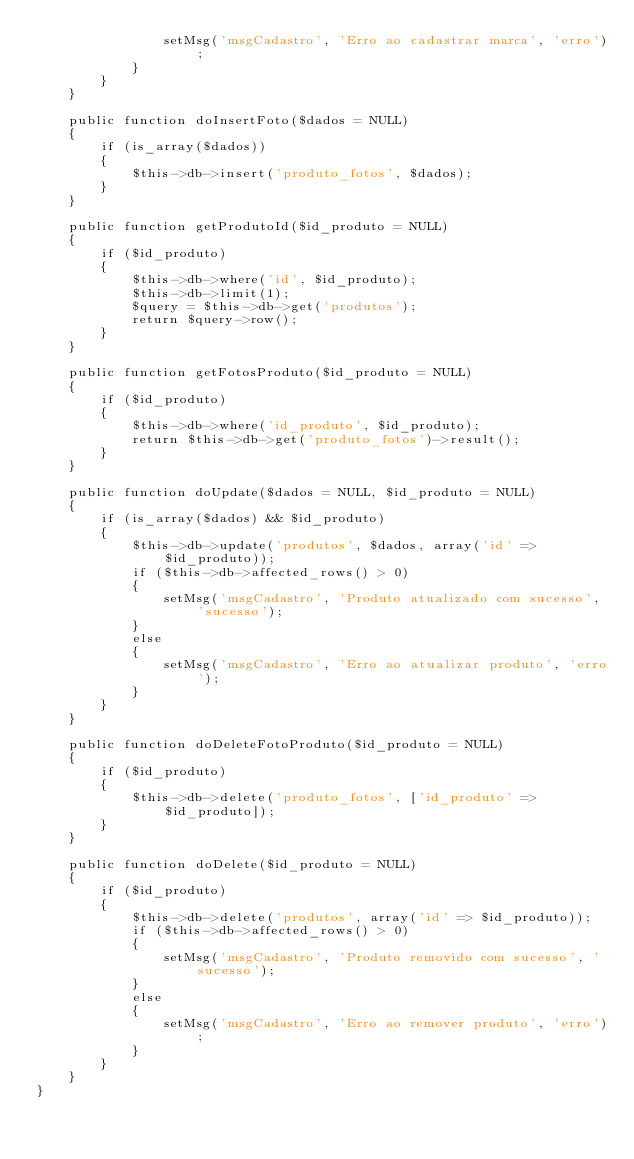<code> <loc_0><loc_0><loc_500><loc_500><_PHP_>				setMsg('msgCadastro', 'Erro ao cadastrar marca', 'erro');
			}
		}
	}

	public function doInsertFoto($dados = NULL)
	{
		if (is_array($dados))
		{
			$this->db->insert('produto_fotos', $dados);
		}
	}

	public function getProdutoId($id_produto = NULL)
	{
		if ($id_produto)
		{
			$this->db->where('id', $id_produto);
			$this->db->limit(1);
			$query = $this->db->get('produtos');
			return $query->row();
		}
	}

	public function getFotosProduto($id_produto = NULL)
	{
		if ($id_produto)
		{
			$this->db->where('id_produto', $id_produto);
			return $this->db->get('produto_fotos')->result();
		}
	}

	public function doUpdate($dados = NULL, $id_produto = NULL)
	{
		if (is_array($dados) && $id_produto)
		{
			$this->db->update('produtos', $dados, array('id' => $id_produto));
			if ($this->db->affected_rows() > 0)
			{
				setMsg('msgCadastro', 'Produto atualizado com sucesso', 'sucesso');
			}
			else
			{
				setMsg('msgCadastro', 'Erro ao atualizar produto', 'erro');
			}
		}
	}

	public function doDeleteFotoProduto($id_produto = NULL)
	{
		if ($id_produto)
		{
			$this->db->delete('produto_fotos', ['id_produto' => $id_produto]);
		}
	}

	public function doDelete($id_produto = NULL)
	{
		if ($id_produto)
		{
			$this->db->delete('produtos', array('id' => $id_produto));
			if ($this->db->affected_rows() > 0)
			{
				setMsg('msgCadastro', 'Produto removido com sucesso', 'sucesso');
			}
			else
			{
				setMsg('msgCadastro', 'Erro ao remover produto', 'erro');
			}
		}
	}
}
</code> 